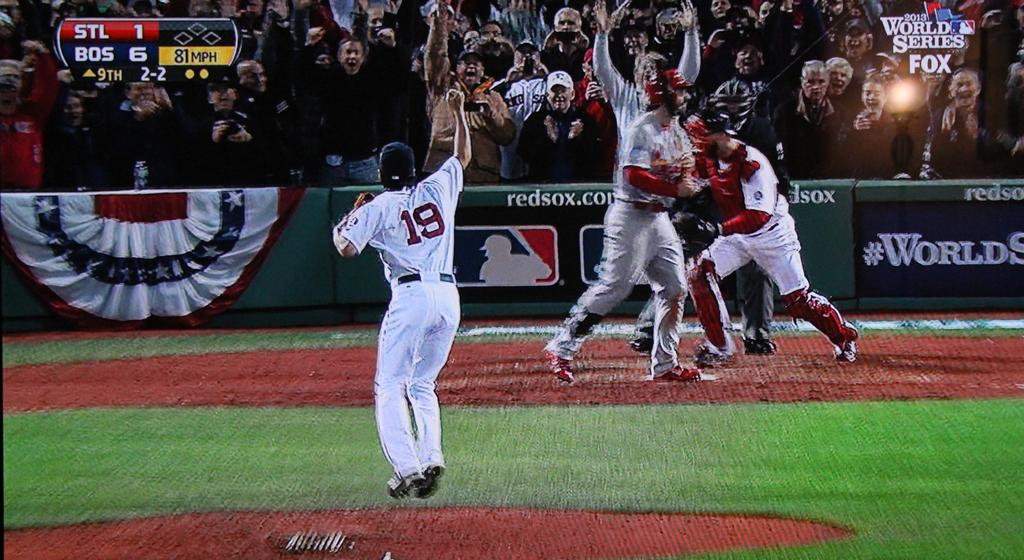Provide a one-sentence caption for the provided image. A baseball pitcher with 19 on his shirt has just thrown an 81 MPH pitch. 